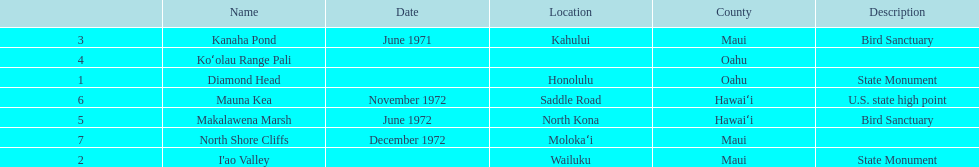How many images are listed? 6. 